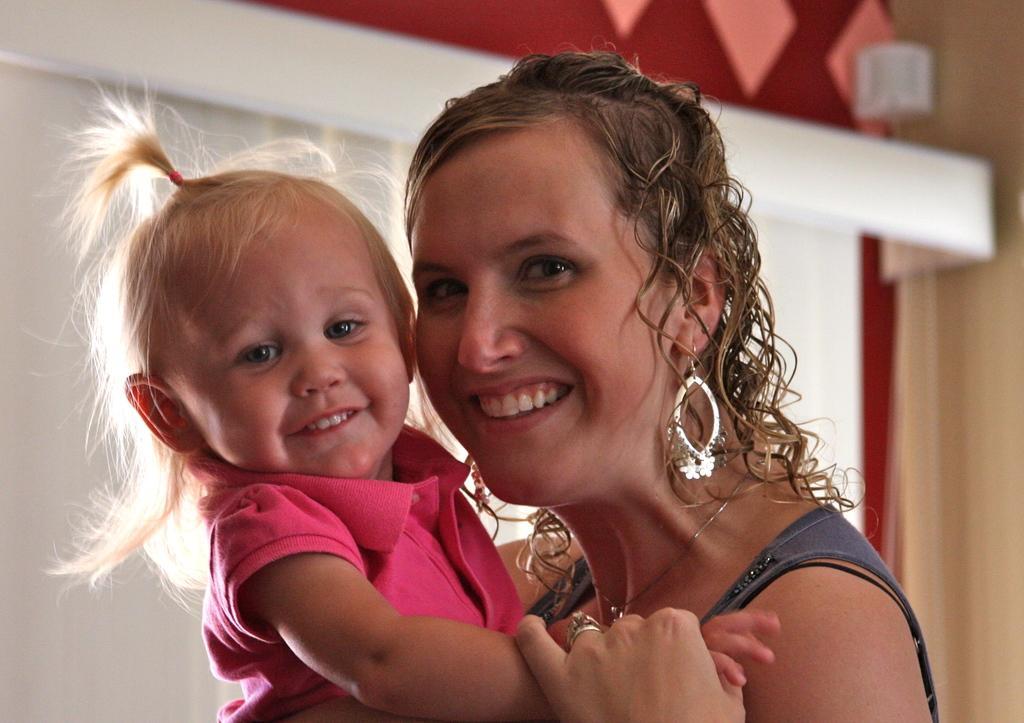In one or two sentences, can you explain what this image depicts? In this image I can see a woman wearing black color dress is smiling and holding a baby wearing pink colored dress. I can see the blurry background. 